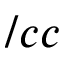Convert formula to latex. <formula><loc_0><loc_0><loc_500><loc_500>/ c c</formula> 